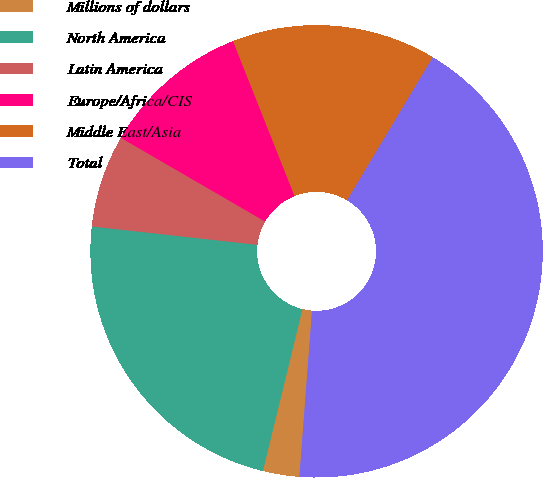Convert chart to OTSL. <chart><loc_0><loc_0><loc_500><loc_500><pie_chart><fcel>Millions of dollars<fcel>North America<fcel>Latin America<fcel>Europe/Africa/CIS<fcel>Middle East/Asia<fcel>Total<nl><fcel>2.61%<fcel>22.94%<fcel>6.61%<fcel>10.61%<fcel>14.61%<fcel>42.61%<nl></chart> 